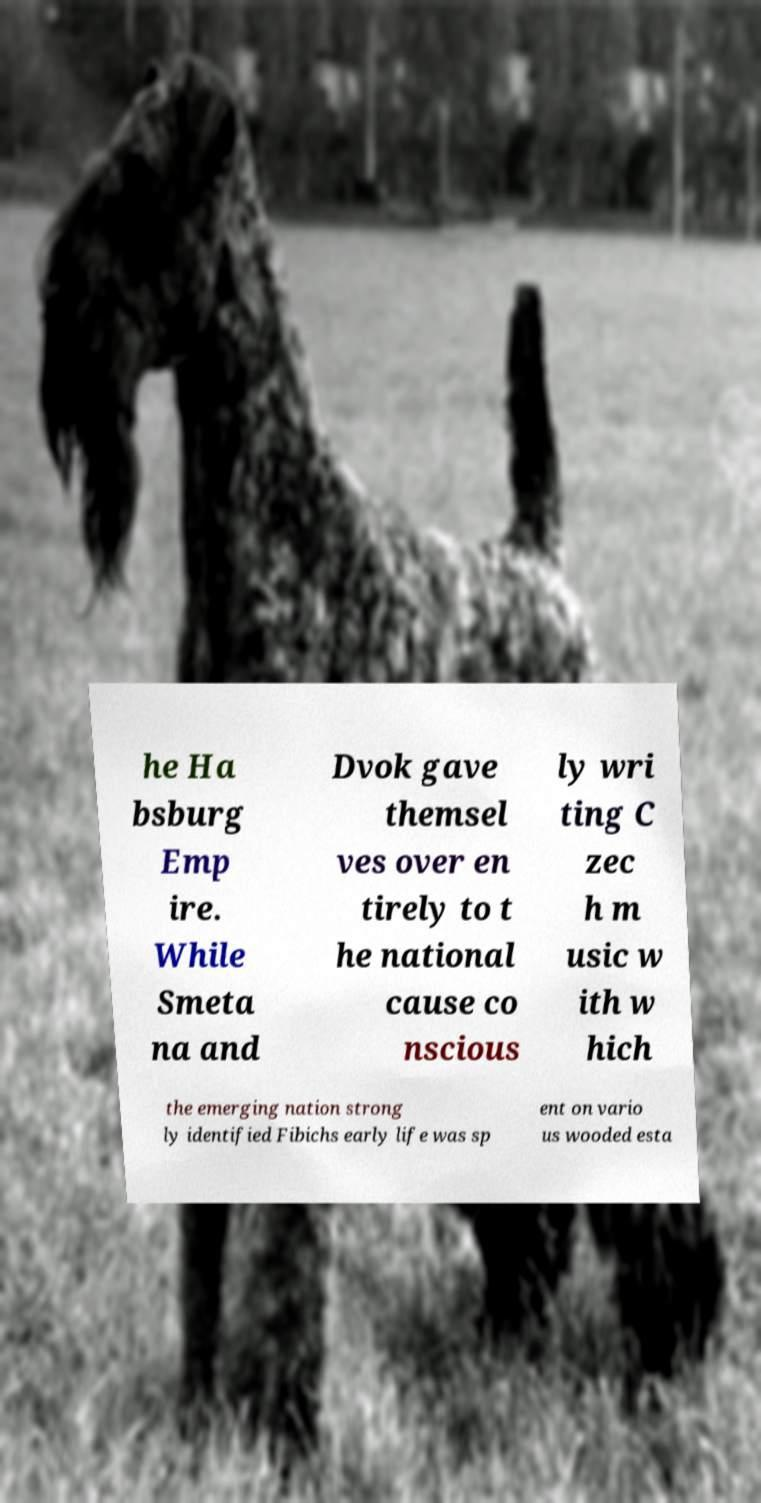I need the written content from this picture converted into text. Can you do that? he Ha bsburg Emp ire. While Smeta na and Dvok gave themsel ves over en tirely to t he national cause co nscious ly wri ting C zec h m usic w ith w hich the emerging nation strong ly identified Fibichs early life was sp ent on vario us wooded esta 